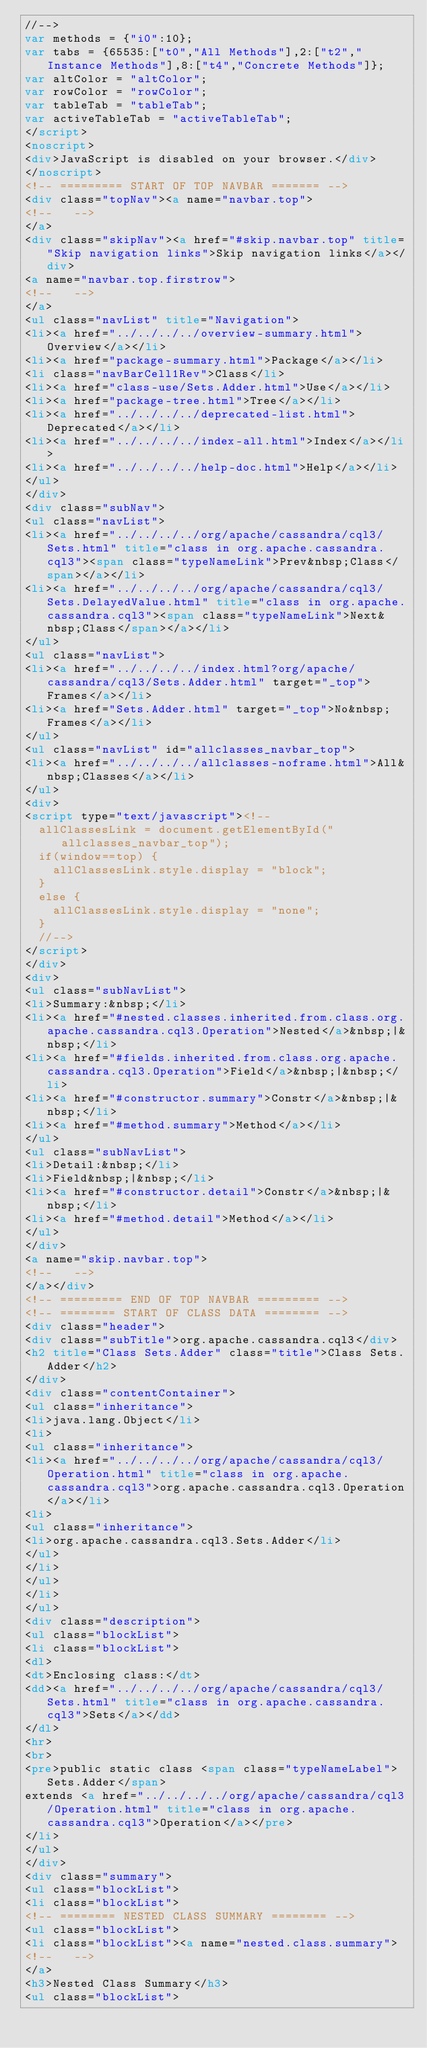Convert code to text. <code><loc_0><loc_0><loc_500><loc_500><_HTML_>//-->
var methods = {"i0":10};
var tabs = {65535:["t0","All Methods"],2:["t2","Instance Methods"],8:["t4","Concrete Methods"]};
var altColor = "altColor";
var rowColor = "rowColor";
var tableTab = "tableTab";
var activeTableTab = "activeTableTab";
</script>
<noscript>
<div>JavaScript is disabled on your browser.</div>
</noscript>
<!-- ========= START OF TOP NAVBAR ======= -->
<div class="topNav"><a name="navbar.top">
<!--   -->
</a>
<div class="skipNav"><a href="#skip.navbar.top" title="Skip navigation links">Skip navigation links</a></div>
<a name="navbar.top.firstrow">
<!--   -->
</a>
<ul class="navList" title="Navigation">
<li><a href="../../../../overview-summary.html">Overview</a></li>
<li><a href="package-summary.html">Package</a></li>
<li class="navBarCell1Rev">Class</li>
<li><a href="class-use/Sets.Adder.html">Use</a></li>
<li><a href="package-tree.html">Tree</a></li>
<li><a href="../../../../deprecated-list.html">Deprecated</a></li>
<li><a href="../../../../index-all.html">Index</a></li>
<li><a href="../../../../help-doc.html">Help</a></li>
</ul>
</div>
<div class="subNav">
<ul class="navList">
<li><a href="../../../../org/apache/cassandra/cql3/Sets.html" title="class in org.apache.cassandra.cql3"><span class="typeNameLink">Prev&nbsp;Class</span></a></li>
<li><a href="../../../../org/apache/cassandra/cql3/Sets.DelayedValue.html" title="class in org.apache.cassandra.cql3"><span class="typeNameLink">Next&nbsp;Class</span></a></li>
</ul>
<ul class="navList">
<li><a href="../../../../index.html?org/apache/cassandra/cql3/Sets.Adder.html" target="_top">Frames</a></li>
<li><a href="Sets.Adder.html" target="_top">No&nbsp;Frames</a></li>
</ul>
<ul class="navList" id="allclasses_navbar_top">
<li><a href="../../../../allclasses-noframe.html">All&nbsp;Classes</a></li>
</ul>
<div>
<script type="text/javascript"><!--
  allClassesLink = document.getElementById("allclasses_navbar_top");
  if(window==top) {
    allClassesLink.style.display = "block";
  }
  else {
    allClassesLink.style.display = "none";
  }
  //-->
</script>
</div>
<div>
<ul class="subNavList">
<li>Summary:&nbsp;</li>
<li><a href="#nested.classes.inherited.from.class.org.apache.cassandra.cql3.Operation">Nested</a>&nbsp;|&nbsp;</li>
<li><a href="#fields.inherited.from.class.org.apache.cassandra.cql3.Operation">Field</a>&nbsp;|&nbsp;</li>
<li><a href="#constructor.summary">Constr</a>&nbsp;|&nbsp;</li>
<li><a href="#method.summary">Method</a></li>
</ul>
<ul class="subNavList">
<li>Detail:&nbsp;</li>
<li>Field&nbsp;|&nbsp;</li>
<li><a href="#constructor.detail">Constr</a>&nbsp;|&nbsp;</li>
<li><a href="#method.detail">Method</a></li>
</ul>
</div>
<a name="skip.navbar.top">
<!--   -->
</a></div>
<!-- ========= END OF TOP NAVBAR ========= -->
<!-- ======== START OF CLASS DATA ======== -->
<div class="header">
<div class="subTitle">org.apache.cassandra.cql3</div>
<h2 title="Class Sets.Adder" class="title">Class Sets.Adder</h2>
</div>
<div class="contentContainer">
<ul class="inheritance">
<li>java.lang.Object</li>
<li>
<ul class="inheritance">
<li><a href="../../../../org/apache/cassandra/cql3/Operation.html" title="class in org.apache.cassandra.cql3">org.apache.cassandra.cql3.Operation</a></li>
<li>
<ul class="inheritance">
<li>org.apache.cassandra.cql3.Sets.Adder</li>
</ul>
</li>
</ul>
</li>
</ul>
<div class="description">
<ul class="blockList">
<li class="blockList">
<dl>
<dt>Enclosing class:</dt>
<dd><a href="../../../../org/apache/cassandra/cql3/Sets.html" title="class in org.apache.cassandra.cql3">Sets</a></dd>
</dl>
<hr>
<br>
<pre>public static class <span class="typeNameLabel">Sets.Adder</span>
extends <a href="../../../../org/apache/cassandra/cql3/Operation.html" title="class in org.apache.cassandra.cql3">Operation</a></pre>
</li>
</ul>
</div>
<div class="summary">
<ul class="blockList">
<li class="blockList">
<!-- ======== NESTED CLASS SUMMARY ======== -->
<ul class="blockList">
<li class="blockList"><a name="nested.class.summary">
<!--   -->
</a>
<h3>Nested Class Summary</h3>
<ul class="blockList"></code> 